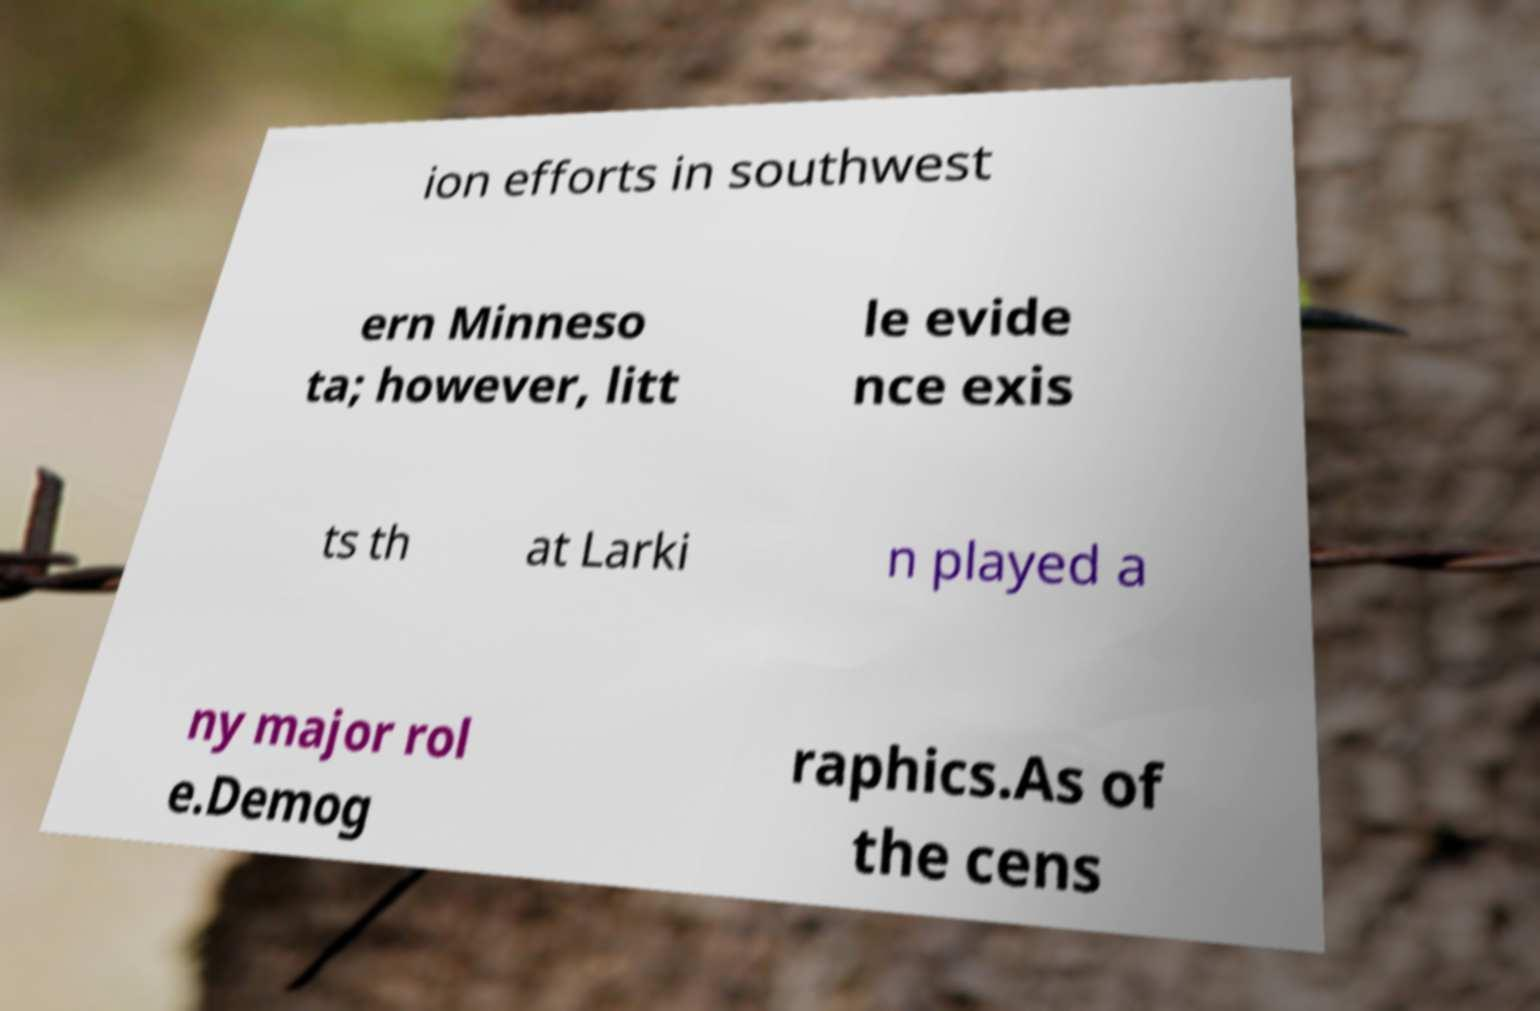Can you accurately transcribe the text from the provided image for me? ion efforts in southwest ern Minneso ta; however, litt le evide nce exis ts th at Larki n played a ny major rol e.Demog raphics.As of the cens 